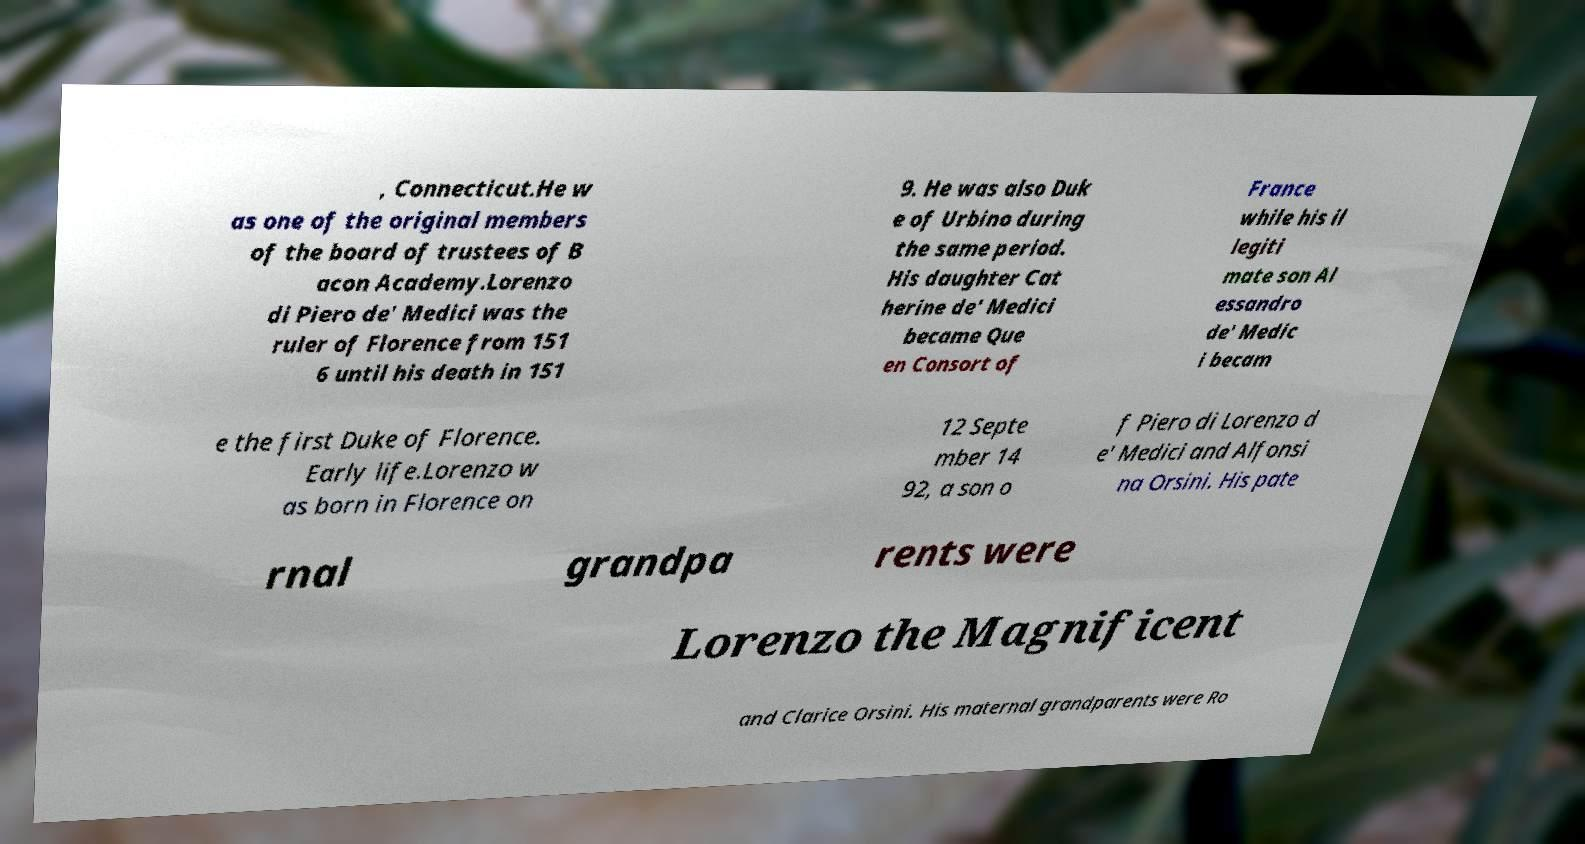I need the written content from this picture converted into text. Can you do that? , Connecticut.He w as one of the original members of the board of trustees of B acon Academy.Lorenzo di Piero de' Medici was the ruler of Florence from 151 6 until his death in 151 9. He was also Duk e of Urbino during the same period. His daughter Cat herine de' Medici became Que en Consort of France while his il legiti mate son Al essandro de' Medic i becam e the first Duke of Florence. Early life.Lorenzo w as born in Florence on 12 Septe mber 14 92, a son o f Piero di Lorenzo d e' Medici and Alfonsi na Orsini. His pate rnal grandpa rents were Lorenzo the Magnificent and Clarice Orsini. His maternal grandparents were Ro 